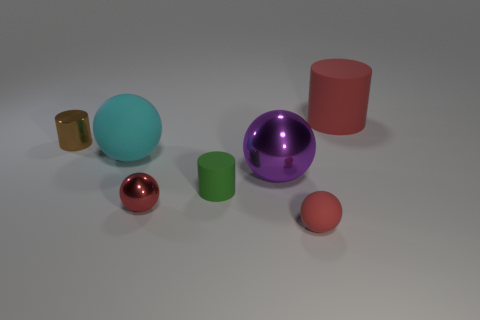Add 2 tiny green things. How many objects exist? 9 Subtract all cylinders. How many objects are left? 4 Add 4 small matte objects. How many small matte objects are left? 6 Add 6 blue shiny spheres. How many blue shiny spheres exist? 6 Subtract 0 blue spheres. How many objects are left? 7 Subtract all small matte objects. Subtract all big red cylinders. How many objects are left? 4 